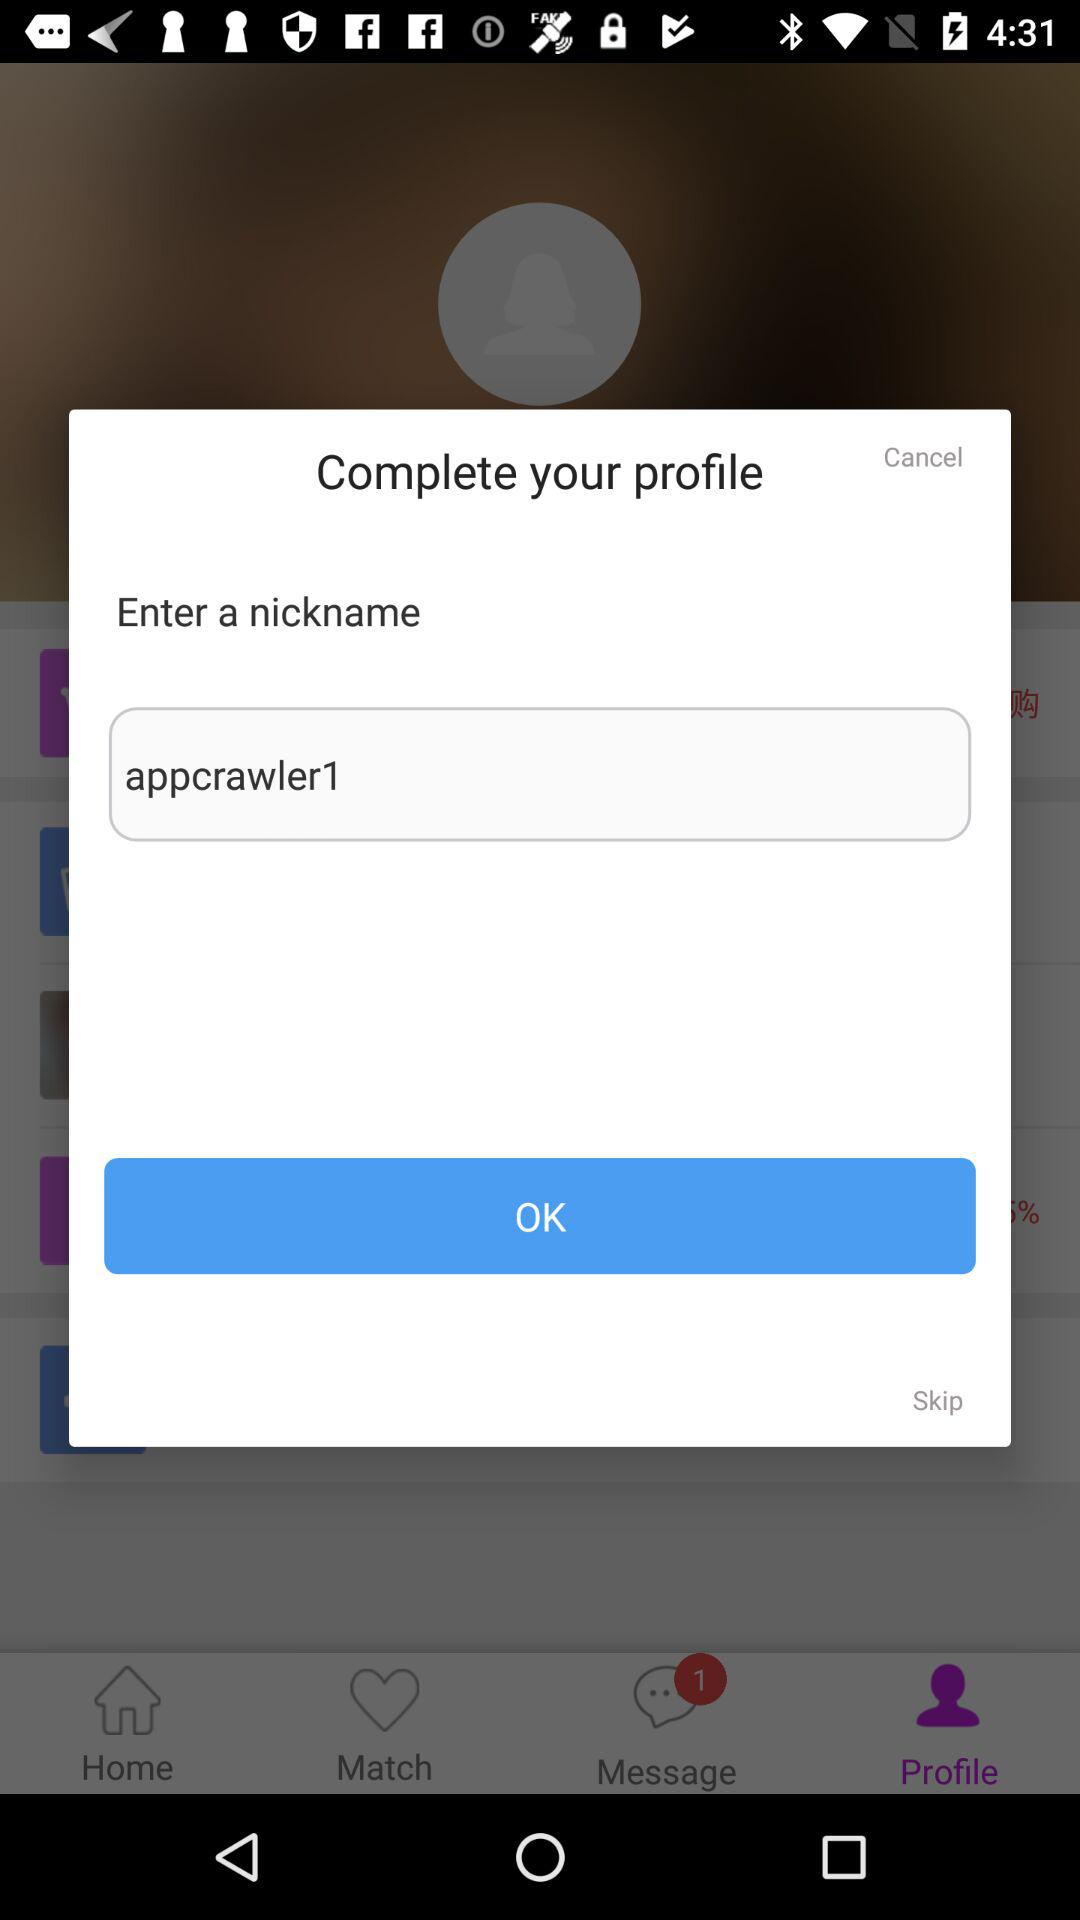What is the username? The username is "appcrawler1". 